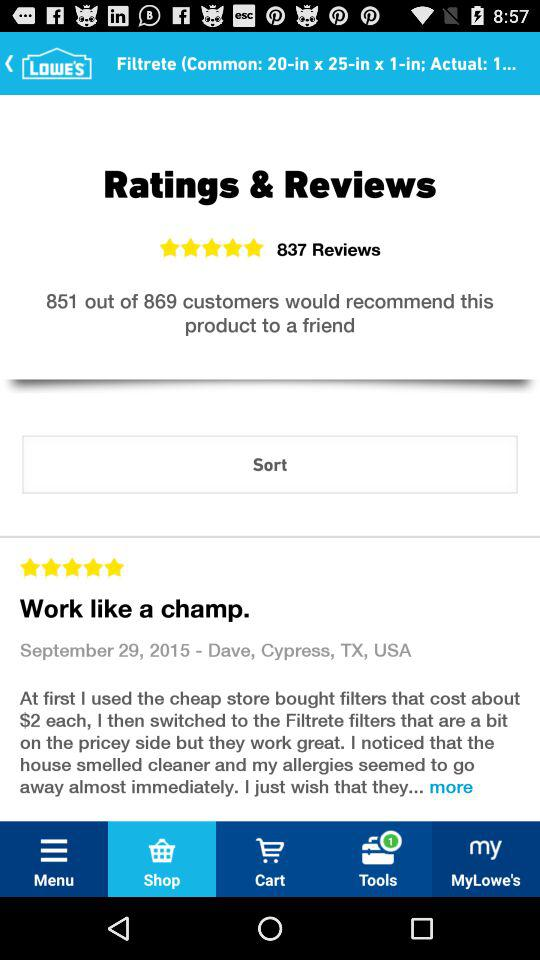How many new notifications are there for "Tools" at the bottom? There is 1 new notification for "Tools" at the bottom. 